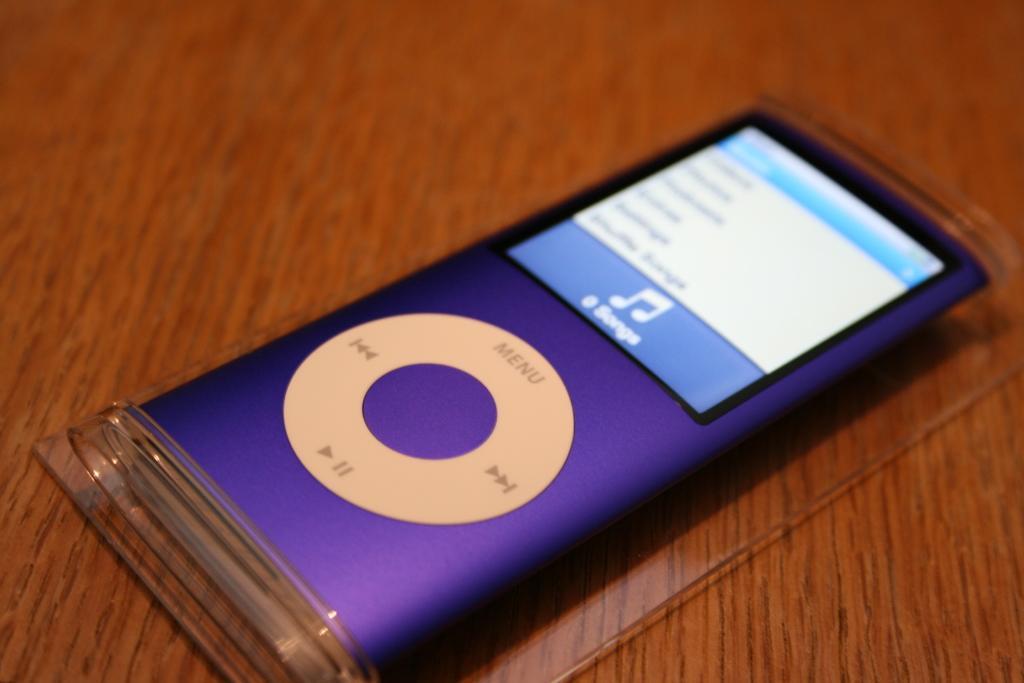How would you summarize this image in a sentence or two? In the image there is an ipod on the wooden table. 